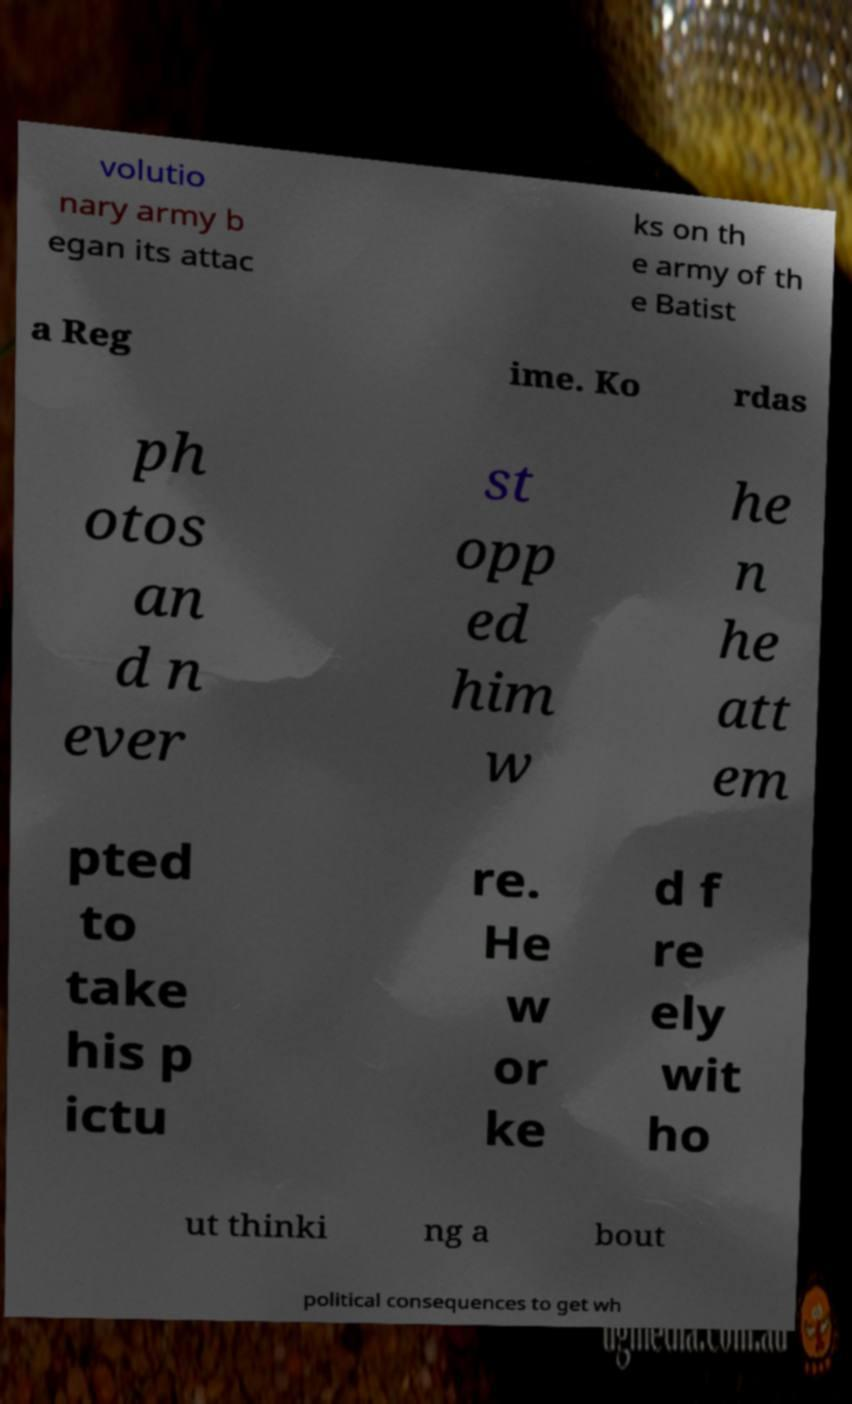I need the written content from this picture converted into text. Can you do that? volutio nary army b egan its attac ks on th e army of th e Batist a Reg ime. Ko rdas ph otos an d n ever st opp ed him w he n he att em pted to take his p ictu re. He w or ke d f re ely wit ho ut thinki ng a bout political consequences to get wh 